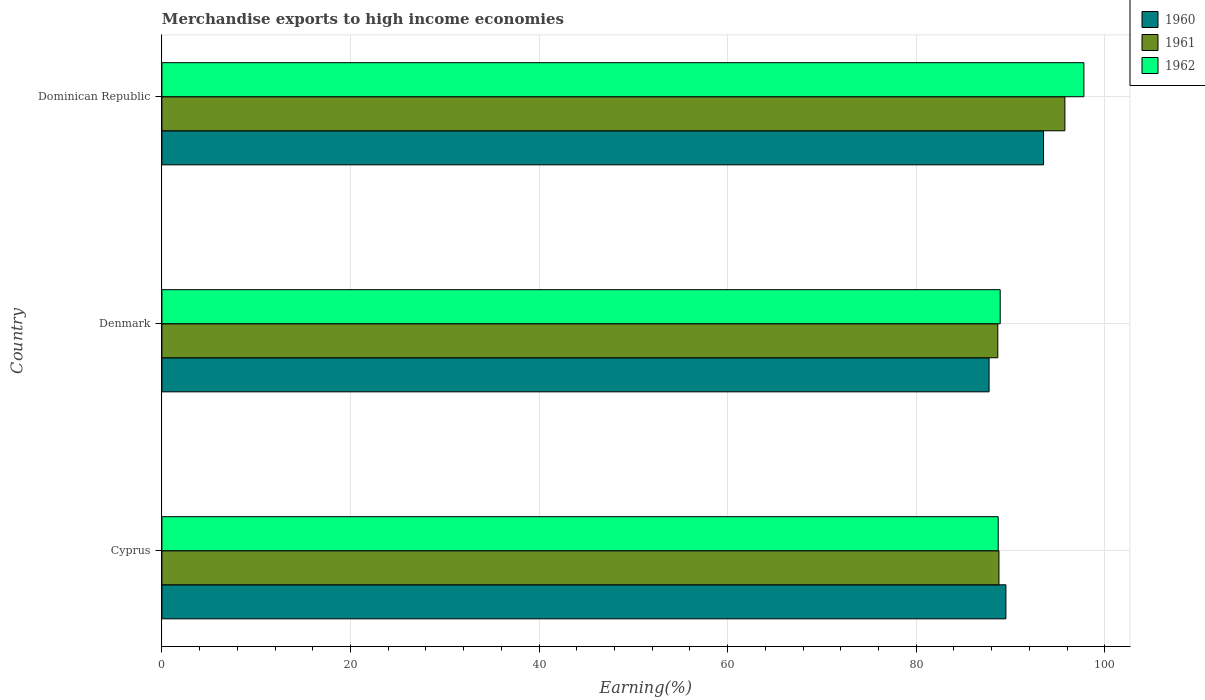Are the number of bars per tick equal to the number of legend labels?
Ensure brevity in your answer.  Yes. Are the number of bars on each tick of the Y-axis equal?
Ensure brevity in your answer.  Yes. How many bars are there on the 3rd tick from the top?
Make the answer very short. 3. How many bars are there on the 2nd tick from the bottom?
Ensure brevity in your answer.  3. What is the label of the 1st group of bars from the top?
Your answer should be very brief. Dominican Republic. What is the percentage of amount earned from merchandise exports in 1962 in Denmark?
Your answer should be compact. 88.91. Across all countries, what is the maximum percentage of amount earned from merchandise exports in 1961?
Your answer should be very brief. 95.77. Across all countries, what is the minimum percentage of amount earned from merchandise exports in 1962?
Ensure brevity in your answer.  88.7. In which country was the percentage of amount earned from merchandise exports in 1961 maximum?
Your answer should be very brief. Dominican Republic. In which country was the percentage of amount earned from merchandise exports in 1962 minimum?
Give a very brief answer. Cyprus. What is the total percentage of amount earned from merchandise exports in 1962 in the graph?
Offer a very short reply. 275.39. What is the difference between the percentage of amount earned from merchandise exports in 1960 in Cyprus and that in Denmark?
Make the answer very short. 1.78. What is the difference between the percentage of amount earned from merchandise exports in 1962 in Cyprus and the percentage of amount earned from merchandise exports in 1960 in Dominican Republic?
Make the answer very short. -4.81. What is the average percentage of amount earned from merchandise exports in 1962 per country?
Give a very brief answer. 91.8. What is the difference between the percentage of amount earned from merchandise exports in 1961 and percentage of amount earned from merchandise exports in 1962 in Dominican Republic?
Your answer should be compact. -2.02. What is the ratio of the percentage of amount earned from merchandise exports in 1961 in Cyprus to that in Denmark?
Provide a succinct answer. 1. Is the difference between the percentage of amount earned from merchandise exports in 1961 in Cyprus and Dominican Republic greater than the difference between the percentage of amount earned from merchandise exports in 1962 in Cyprus and Dominican Republic?
Provide a succinct answer. Yes. What is the difference between the highest and the second highest percentage of amount earned from merchandise exports in 1961?
Offer a very short reply. 6.99. What is the difference between the highest and the lowest percentage of amount earned from merchandise exports in 1962?
Offer a very short reply. 9.09. What does the 3rd bar from the top in Dominican Republic represents?
Your answer should be compact. 1960. What does the 1st bar from the bottom in Cyprus represents?
Give a very brief answer. 1960. Is it the case that in every country, the sum of the percentage of amount earned from merchandise exports in 1962 and percentage of amount earned from merchandise exports in 1961 is greater than the percentage of amount earned from merchandise exports in 1960?
Ensure brevity in your answer.  Yes. How many bars are there?
Offer a terse response. 9. How many countries are there in the graph?
Provide a succinct answer. 3. What is the difference between two consecutive major ticks on the X-axis?
Make the answer very short. 20. Are the values on the major ticks of X-axis written in scientific E-notation?
Provide a short and direct response. No. Does the graph contain grids?
Keep it short and to the point. Yes. How many legend labels are there?
Keep it short and to the point. 3. How are the legend labels stacked?
Ensure brevity in your answer.  Vertical. What is the title of the graph?
Provide a short and direct response. Merchandise exports to high income economies. What is the label or title of the X-axis?
Your answer should be very brief. Earning(%). What is the label or title of the Y-axis?
Your response must be concise. Country. What is the Earning(%) of 1960 in Cyprus?
Your answer should be compact. 89.51. What is the Earning(%) of 1961 in Cyprus?
Offer a terse response. 88.78. What is the Earning(%) in 1962 in Cyprus?
Give a very brief answer. 88.7. What is the Earning(%) in 1960 in Denmark?
Give a very brief answer. 87.73. What is the Earning(%) of 1961 in Denmark?
Offer a very short reply. 88.66. What is the Earning(%) in 1962 in Denmark?
Make the answer very short. 88.91. What is the Earning(%) in 1960 in Dominican Republic?
Offer a very short reply. 93.51. What is the Earning(%) in 1961 in Dominican Republic?
Keep it short and to the point. 95.77. What is the Earning(%) in 1962 in Dominican Republic?
Keep it short and to the point. 97.78. Across all countries, what is the maximum Earning(%) of 1960?
Provide a succinct answer. 93.51. Across all countries, what is the maximum Earning(%) of 1961?
Give a very brief answer. 95.77. Across all countries, what is the maximum Earning(%) of 1962?
Offer a very short reply. 97.78. Across all countries, what is the minimum Earning(%) of 1960?
Provide a succinct answer. 87.73. Across all countries, what is the minimum Earning(%) in 1961?
Your answer should be compact. 88.66. Across all countries, what is the minimum Earning(%) of 1962?
Your answer should be compact. 88.7. What is the total Earning(%) in 1960 in the graph?
Your response must be concise. 270.75. What is the total Earning(%) in 1961 in the graph?
Provide a short and direct response. 273.2. What is the total Earning(%) in 1962 in the graph?
Provide a succinct answer. 275.39. What is the difference between the Earning(%) of 1960 in Cyprus and that in Denmark?
Provide a succinct answer. 1.78. What is the difference between the Earning(%) of 1961 in Cyprus and that in Denmark?
Your answer should be compact. 0.12. What is the difference between the Earning(%) of 1962 in Cyprus and that in Denmark?
Provide a succinct answer. -0.21. What is the difference between the Earning(%) in 1960 in Cyprus and that in Dominican Republic?
Keep it short and to the point. -3.99. What is the difference between the Earning(%) in 1961 in Cyprus and that in Dominican Republic?
Offer a very short reply. -6.99. What is the difference between the Earning(%) in 1962 in Cyprus and that in Dominican Republic?
Your answer should be very brief. -9.09. What is the difference between the Earning(%) of 1960 in Denmark and that in Dominican Republic?
Keep it short and to the point. -5.78. What is the difference between the Earning(%) of 1961 in Denmark and that in Dominican Republic?
Give a very brief answer. -7.11. What is the difference between the Earning(%) of 1962 in Denmark and that in Dominican Republic?
Offer a terse response. -8.88. What is the difference between the Earning(%) in 1960 in Cyprus and the Earning(%) in 1961 in Denmark?
Your answer should be very brief. 0.86. What is the difference between the Earning(%) of 1960 in Cyprus and the Earning(%) of 1962 in Denmark?
Provide a short and direct response. 0.6. What is the difference between the Earning(%) in 1961 in Cyprus and the Earning(%) in 1962 in Denmark?
Keep it short and to the point. -0.13. What is the difference between the Earning(%) of 1960 in Cyprus and the Earning(%) of 1961 in Dominican Republic?
Provide a short and direct response. -6.26. What is the difference between the Earning(%) in 1960 in Cyprus and the Earning(%) in 1962 in Dominican Republic?
Provide a short and direct response. -8.27. What is the difference between the Earning(%) in 1961 in Cyprus and the Earning(%) in 1962 in Dominican Republic?
Provide a short and direct response. -9.01. What is the difference between the Earning(%) of 1960 in Denmark and the Earning(%) of 1961 in Dominican Republic?
Provide a short and direct response. -8.04. What is the difference between the Earning(%) of 1960 in Denmark and the Earning(%) of 1962 in Dominican Republic?
Provide a short and direct response. -10.06. What is the difference between the Earning(%) in 1961 in Denmark and the Earning(%) in 1962 in Dominican Republic?
Offer a very short reply. -9.13. What is the average Earning(%) in 1960 per country?
Ensure brevity in your answer.  90.25. What is the average Earning(%) of 1961 per country?
Your answer should be compact. 91.07. What is the average Earning(%) in 1962 per country?
Offer a very short reply. 91.8. What is the difference between the Earning(%) of 1960 and Earning(%) of 1961 in Cyprus?
Offer a terse response. 0.74. What is the difference between the Earning(%) in 1960 and Earning(%) in 1962 in Cyprus?
Make the answer very short. 0.82. What is the difference between the Earning(%) of 1961 and Earning(%) of 1962 in Cyprus?
Provide a short and direct response. 0.08. What is the difference between the Earning(%) of 1960 and Earning(%) of 1961 in Denmark?
Ensure brevity in your answer.  -0.93. What is the difference between the Earning(%) of 1960 and Earning(%) of 1962 in Denmark?
Make the answer very short. -1.18. What is the difference between the Earning(%) in 1961 and Earning(%) in 1962 in Denmark?
Your answer should be very brief. -0.25. What is the difference between the Earning(%) in 1960 and Earning(%) in 1961 in Dominican Republic?
Your answer should be compact. -2.26. What is the difference between the Earning(%) in 1960 and Earning(%) in 1962 in Dominican Republic?
Give a very brief answer. -4.28. What is the difference between the Earning(%) of 1961 and Earning(%) of 1962 in Dominican Republic?
Provide a succinct answer. -2.02. What is the ratio of the Earning(%) of 1960 in Cyprus to that in Denmark?
Make the answer very short. 1.02. What is the ratio of the Earning(%) of 1961 in Cyprus to that in Denmark?
Provide a succinct answer. 1. What is the ratio of the Earning(%) in 1962 in Cyprus to that in Denmark?
Ensure brevity in your answer.  1. What is the ratio of the Earning(%) of 1960 in Cyprus to that in Dominican Republic?
Make the answer very short. 0.96. What is the ratio of the Earning(%) of 1961 in Cyprus to that in Dominican Republic?
Offer a very short reply. 0.93. What is the ratio of the Earning(%) in 1962 in Cyprus to that in Dominican Republic?
Your answer should be very brief. 0.91. What is the ratio of the Earning(%) of 1960 in Denmark to that in Dominican Republic?
Offer a very short reply. 0.94. What is the ratio of the Earning(%) of 1961 in Denmark to that in Dominican Republic?
Keep it short and to the point. 0.93. What is the ratio of the Earning(%) in 1962 in Denmark to that in Dominican Republic?
Ensure brevity in your answer.  0.91. What is the difference between the highest and the second highest Earning(%) of 1960?
Make the answer very short. 3.99. What is the difference between the highest and the second highest Earning(%) in 1961?
Your response must be concise. 6.99. What is the difference between the highest and the second highest Earning(%) of 1962?
Ensure brevity in your answer.  8.88. What is the difference between the highest and the lowest Earning(%) of 1960?
Keep it short and to the point. 5.78. What is the difference between the highest and the lowest Earning(%) of 1961?
Offer a very short reply. 7.11. What is the difference between the highest and the lowest Earning(%) in 1962?
Your answer should be compact. 9.09. 